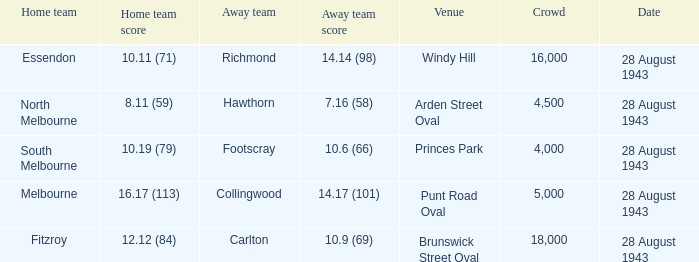17 (101)? Punt Road Oval. 